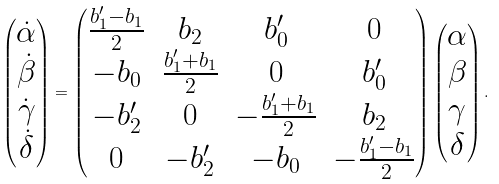Convert formula to latex. <formula><loc_0><loc_0><loc_500><loc_500>\left ( \begin{matrix} \dot { \alpha } \\ \dot { \beta } \\ \dot { \gamma } \\ \dot { \delta } \end{matrix} \right ) = \left ( \begin{matrix} \frac { b ^ { \prime } _ { 1 } - b _ { 1 } } { 2 } & b _ { 2 } & b ^ { \prime } _ { 0 } & 0 \\ - b _ { 0 } & \frac { b ^ { \prime } _ { 1 } + b _ { 1 } } { 2 } & 0 & b ^ { \prime } _ { 0 } \\ - b ^ { \prime } _ { 2 } & 0 & - \frac { b ^ { \prime } _ { 1 } + b _ { 1 } } { 2 } & b _ { 2 } \\ 0 & - b _ { 2 } ^ { \prime } & - b _ { 0 } & - \frac { b ^ { \prime } _ { 1 } - b _ { 1 } } { 2 } \end{matrix} \right ) \left ( \begin{matrix} \alpha \\ \beta \\ \gamma \\ \delta \end{matrix} \right ) .</formula> 